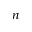<formula> <loc_0><loc_0><loc_500><loc_500>n</formula> 